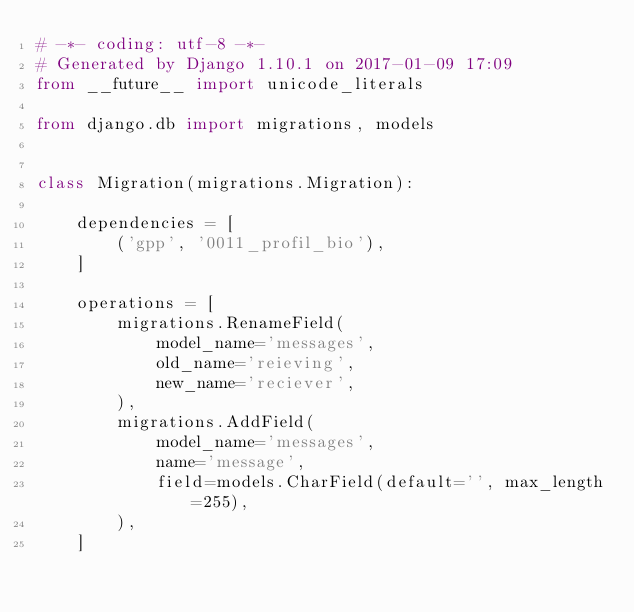Convert code to text. <code><loc_0><loc_0><loc_500><loc_500><_Python_># -*- coding: utf-8 -*-
# Generated by Django 1.10.1 on 2017-01-09 17:09
from __future__ import unicode_literals

from django.db import migrations, models


class Migration(migrations.Migration):

    dependencies = [
        ('gpp', '0011_profil_bio'),
    ]

    operations = [
        migrations.RenameField(
            model_name='messages',
            old_name='reieving',
            new_name='reciever',
        ),
        migrations.AddField(
            model_name='messages',
            name='message',
            field=models.CharField(default='', max_length=255),
        ),
    ]
</code> 